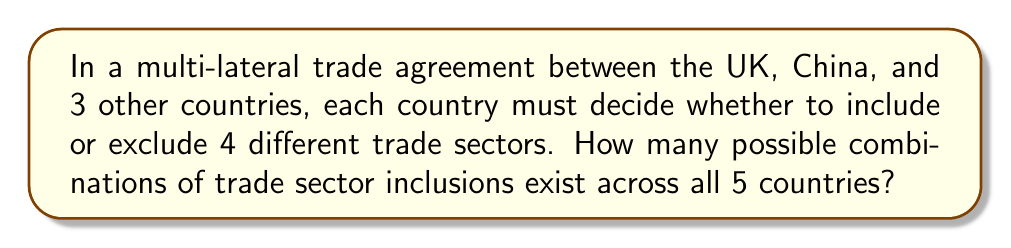Teach me how to tackle this problem. Let's approach this step-by-step:

1) First, we need to understand what we're counting. For each country, there are 4 trade sectors, and each sector can be either included or excluded.

2) For a single country and a single sector, there are 2 possibilities (include or exclude).

3) For a single country considering all 4 sectors, we have 2 choices for each sector. This can be represented as:

   $2 \times 2 \times 2 \times 2 = 2^4 = 16$ possibilities per country

4) Now, we have 5 countries (UK, China, and 3 others), each with 16 possible configurations.

5) To find the total number of possible combinations across all countries, we multiply the number of possibilities for each country:

   $16 \times 16 \times 16 \times 16 \times 16 = 16^5$

6) We can simplify this further:

   $16^5 = (2^4)^5 = 2^{20}$

Therefore, the total number of possible combinations is $2^{20}$.
Answer: $2^{20}$ 